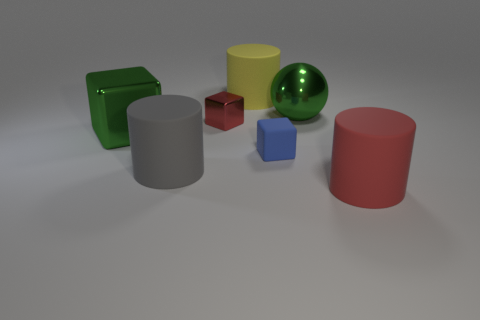Add 1 large green cylinders. How many objects exist? 8 Subtract all cubes. How many objects are left? 4 Subtract all small green metallic spheres. Subtract all big yellow cylinders. How many objects are left? 6 Add 3 rubber things. How many rubber things are left? 7 Add 2 gray rubber things. How many gray rubber things exist? 3 Subtract 0 red spheres. How many objects are left? 7 